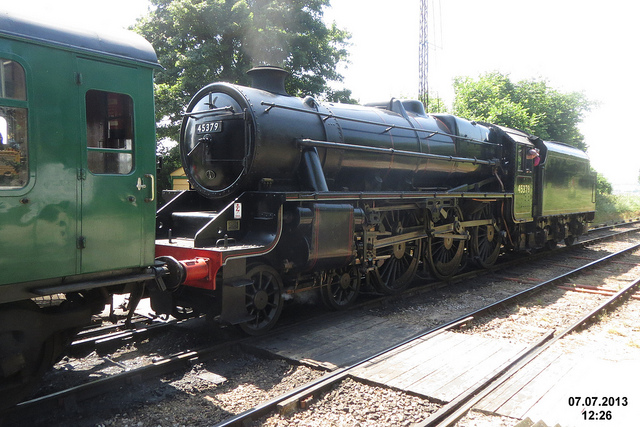Who invented this vehicle?
A. richard trevithick
B. orville wright
C. jeff goldblum
D. bill nye The correct answer is A, Richard Trevithick. He was a British inventor and mining engineer from Cornwall, England. His most significant contribution to technology was the high-pressure steam engine and he also built the first full-scale working railway steam locomotive. On February 21, 1804, the world's first railway journey took place as Trevithick’s steam locomotive hauled a train along the tramway of the Penydarren ironworks, in Merthyr Tydfil, Wales. 